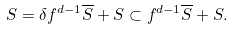<formula> <loc_0><loc_0><loc_500><loc_500>S = \delta f ^ { d - 1 } \overline { S } + S \subset f ^ { d - 1 } \overline { S } + S .</formula> 